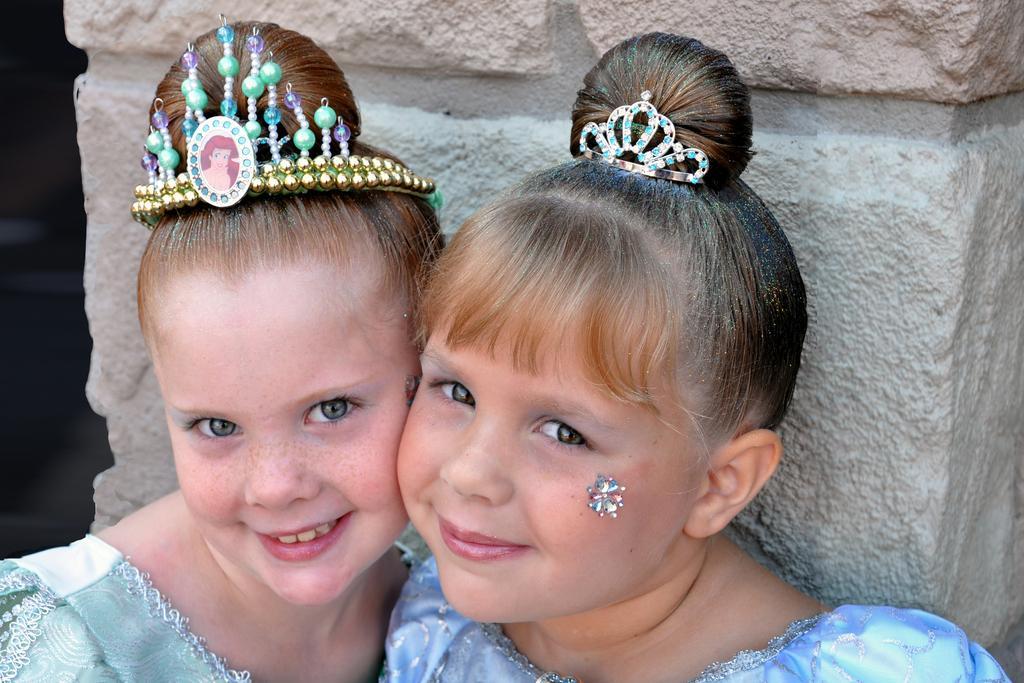Could you give a brief overview of what you see in this image? In the image I can see two people smiling and wearing blue color dress and different head wears. Back I can see a rock-pillar. 